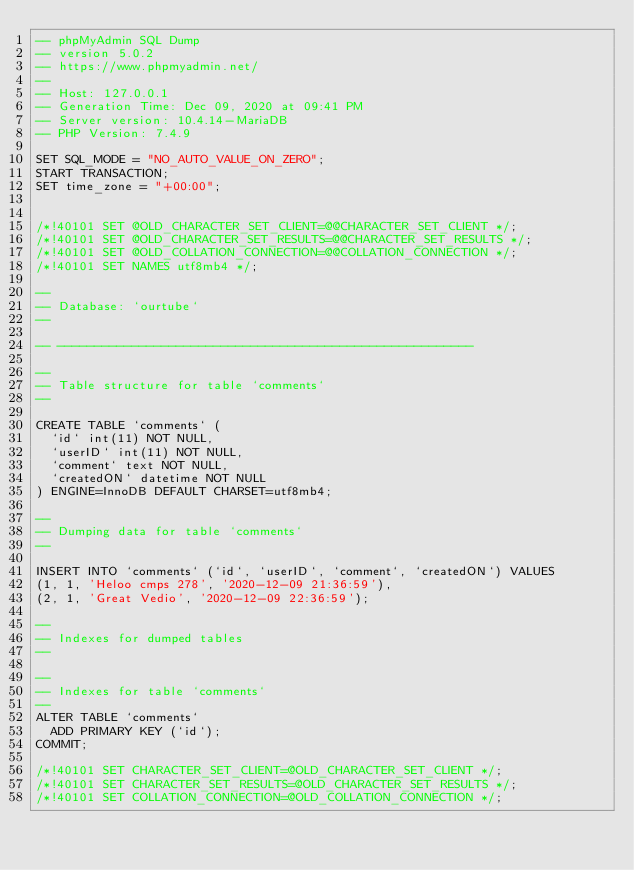Convert code to text. <code><loc_0><loc_0><loc_500><loc_500><_SQL_>-- phpMyAdmin SQL Dump
-- version 5.0.2
-- https://www.phpmyadmin.net/
--
-- Host: 127.0.0.1
-- Generation Time: Dec 09, 2020 at 09:41 PM
-- Server version: 10.4.14-MariaDB
-- PHP Version: 7.4.9

SET SQL_MODE = "NO_AUTO_VALUE_ON_ZERO";
START TRANSACTION;
SET time_zone = "+00:00";


/*!40101 SET @OLD_CHARACTER_SET_CLIENT=@@CHARACTER_SET_CLIENT */;
/*!40101 SET @OLD_CHARACTER_SET_RESULTS=@@CHARACTER_SET_RESULTS */;
/*!40101 SET @OLD_COLLATION_CONNECTION=@@COLLATION_CONNECTION */;
/*!40101 SET NAMES utf8mb4 */;

--
-- Database: `ourtube`
--

-- --------------------------------------------------------

--
-- Table structure for table `comments`
--

CREATE TABLE `comments` (
  `id` int(11) NOT NULL,
  `userID` int(11) NOT NULL,
  `comment` text NOT NULL,
  `createdON` datetime NOT NULL
) ENGINE=InnoDB DEFAULT CHARSET=utf8mb4;

--
-- Dumping data for table `comments`
--

INSERT INTO `comments` (`id`, `userID`, `comment`, `createdON`) VALUES
(1, 1, 'Heloo cmps 278', '2020-12-09 21:36:59'),
(2, 1, 'Great Vedio', '2020-12-09 22:36:59');

--
-- Indexes for dumped tables
--

--
-- Indexes for table `comments`
--
ALTER TABLE `comments`
  ADD PRIMARY KEY (`id`);
COMMIT;

/*!40101 SET CHARACTER_SET_CLIENT=@OLD_CHARACTER_SET_CLIENT */;
/*!40101 SET CHARACTER_SET_RESULTS=@OLD_CHARACTER_SET_RESULTS */;
/*!40101 SET COLLATION_CONNECTION=@OLD_COLLATION_CONNECTION */;
</code> 